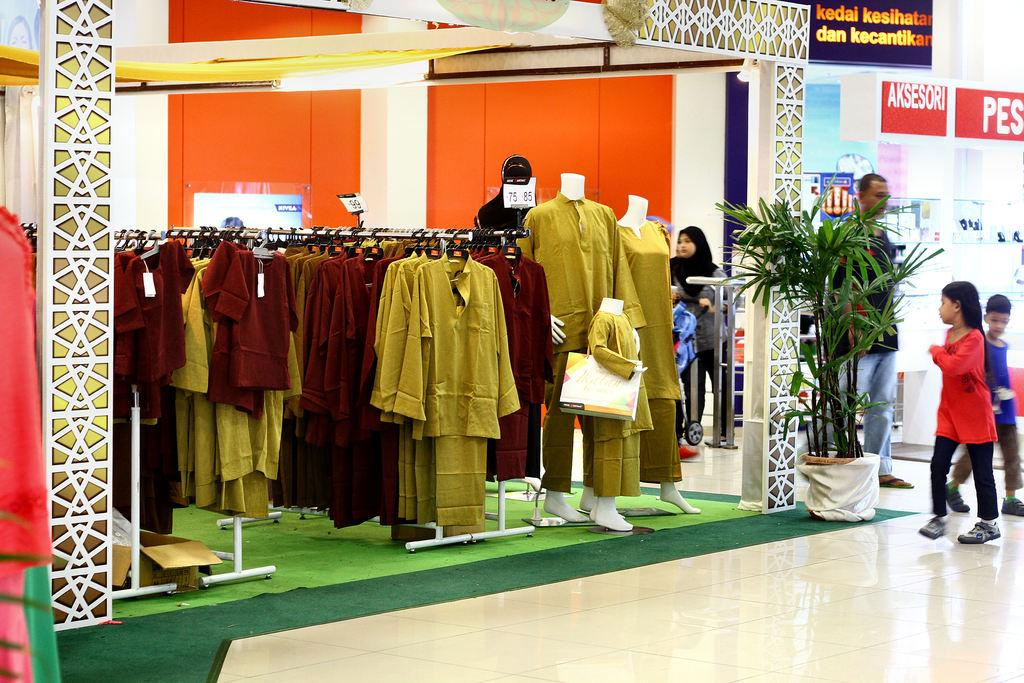What is being displayed on the poles in the image? There are clothes hanged on poles in the image. What type of clothing can be seen on mannequins in the image? There are dresses on mannequins in the image. What kind of decorative item is present in the image? There is a flowerpot in the image. What type of storage containers are visible in the image? Cardboard boxes are present in the image. What material are the visible boards made of? The boards are visible in the image, but their material is not specified. Can you describe the people in the image? There are people in the image, but their specific actions or characteristics are not mentioned in the provided facts. What type of establishment is depicted in the image? The image contains a store. Where is the pencil located in the image? There is no pencil present in the image. What color is the balloon that is tied to the clothesline? There is no balloon present in the image. 